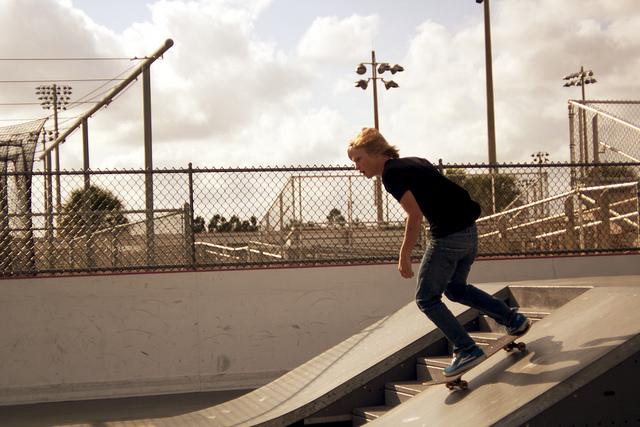Is this picture in black and white?
Be succinct. No. Is the person airborne?
Give a very brief answer. No. Is he going up or down the ramp?
Be succinct. Down. Is the boy skateboarding?
Answer briefly. Yes. Where is the boy skateboarding?
Quick response, please. Skate park. 